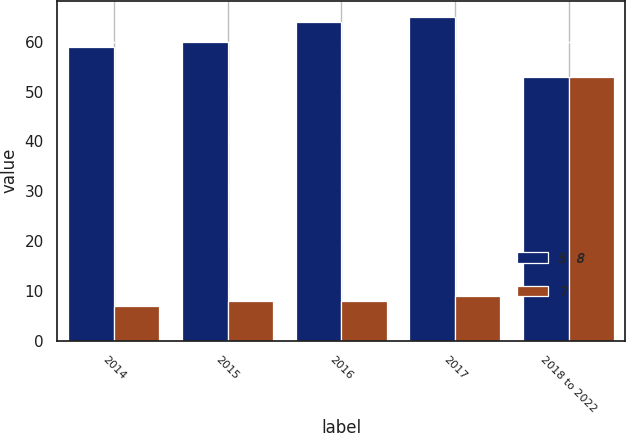Convert chart. <chart><loc_0><loc_0><loc_500><loc_500><stacked_bar_chart><ecel><fcel>2014<fcel>2015<fcel>2016<fcel>2017<fcel>2018 to 2022<nl><fcel>5 8<fcel>59<fcel>60<fcel>64<fcel>65<fcel>53<nl><fcel>7<fcel>7<fcel>8<fcel>8<fcel>9<fcel>53<nl></chart> 